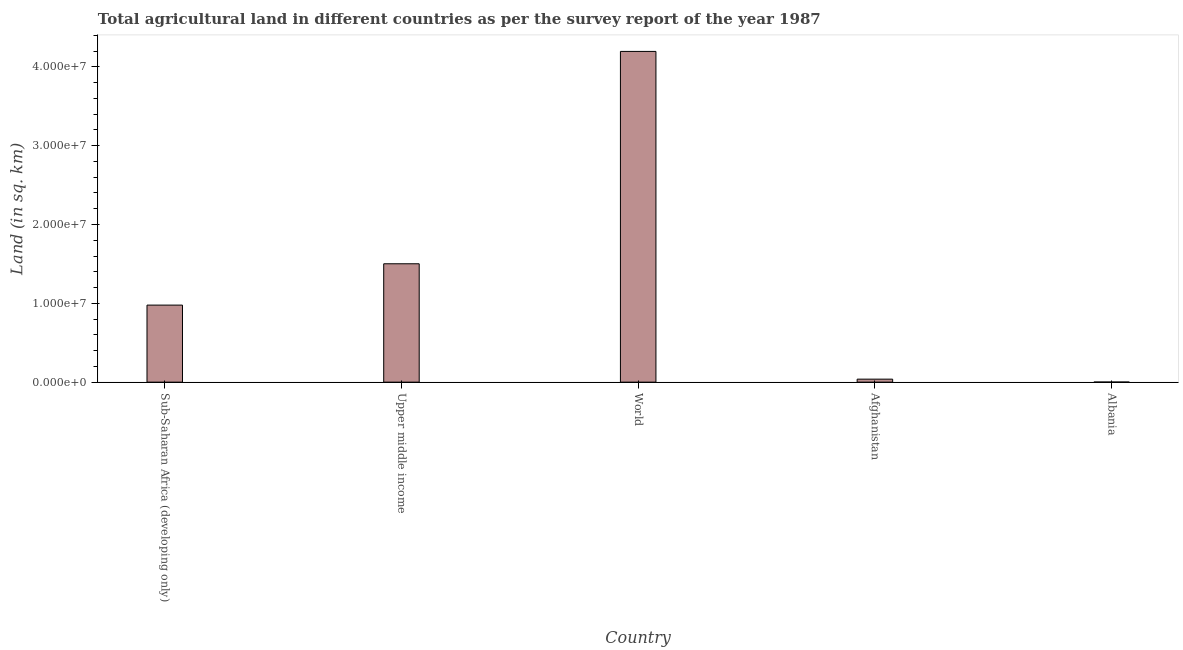Does the graph contain any zero values?
Offer a very short reply. No. Does the graph contain grids?
Ensure brevity in your answer.  No. What is the title of the graph?
Keep it short and to the point. Total agricultural land in different countries as per the survey report of the year 1987. What is the label or title of the X-axis?
Keep it short and to the point. Country. What is the label or title of the Y-axis?
Your response must be concise. Land (in sq. km). What is the agricultural land in Upper middle income?
Your answer should be compact. 1.50e+07. Across all countries, what is the maximum agricultural land?
Provide a succinct answer. 4.20e+07. Across all countries, what is the minimum agricultural land?
Your response must be concise. 1.11e+04. In which country was the agricultural land minimum?
Offer a terse response. Albania. What is the sum of the agricultural land?
Keep it short and to the point. 6.71e+07. What is the difference between the agricultural land in Albania and Sub-Saharan Africa (developing only)?
Your response must be concise. -9.76e+06. What is the average agricultural land per country?
Your answer should be very brief. 1.34e+07. What is the median agricultural land?
Provide a succinct answer. 9.77e+06. In how many countries, is the agricultural land greater than 2000000 sq. km?
Ensure brevity in your answer.  3. What is the ratio of the agricultural land in Afghanistan to that in Upper middle income?
Ensure brevity in your answer.  0.03. Is the difference between the agricultural land in Albania and Sub-Saharan Africa (developing only) greater than the difference between any two countries?
Make the answer very short. No. What is the difference between the highest and the second highest agricultural land?
Provide a succinct answer. 2.69e+07. What is the difference between the highest and the lowest agricultural land?
Provide a short and direct response. 4.19e+07. How many bars are there?
Your answer should be very brief. 5. Are all the bars in the graph horizontal?
Keep it short and to the point. No. What is the difference between two consecutive major ticks on the Y-axis?
Give a very brief answer. 1.00e+07. Are the values on the major ticks of Y-axis written in scientific E-notation?
Make the answer very short. Yes. What is the Land (in sq. km) of Sub-Saharan Africa (developing only)?
Offer a very short reply. 9.77e+06. What is the Land (in sq. km) in Upper middle income?
Make the answer very short. 1.50e+07. What is the Land (in sq. km) of World?
Keep it short and to the point. 4.20e+07. What is the Land (in sq. km) of Afghanistan?
Your response must be concise. 3.80e+05. What is the Land (in sq. km) in Albania?
Provide a succinct answer. 1.11e+04. What is the difference between the Land (in sq. km) in Sub-Saharan Africa (developing only) and Upper middle income?
Make the answer very short. -5.24e+06. What is the difference between the Land (in sq. km) in Sub-Saharan Africa (developing only) and World?
Keep it short and to the point. -3.22e+07. What is the difference between the Land (in sq. km) in Sub-Saharan Africa (developing only) and Afghanistan?
Offer a very short reply. 9.39e+06. What is the difference between the Land (in sq. km) in Sub-Saharan Africa (developing only) and Albania?
Keep it short and to the point. 9.76e+06. What is the difference between the Land (in sq. km) in Upper middle income and World?
Your answer should be very brief. -2.69e+07. What is the difference between the Land (in sq. km) in Upper middle income and Afghanistan?
Make the answer very short. 1.46e+07. What is the difference between the Land (in sq. km) in Upper middle income and Albania?
Provide a short and direct response. 1.50e+07. What is the difference between the Land (in sq. km) in World and Afghanistan?
Keep it short and to the point. 4.16e+07. What is the difference between the Land (in sq. km) in World and Albania?
Offer a very short reply. 4.19e+07. What is the difference between the Land (in sq. km) in Afghanistan and Albania?
Offer a terse response. 3.69e+05. What is the ratio of the Land (in sq. km) in Sub-Saharan Africa (developing only) to that in Upper middle income?
Provide a short and direct response. 0.65. What is the ratio of the Land (in sq. km) in Sub-Saharan Africa (developing only) to that in World?
Keep it short and to the point. 0.23. What is the ratio of the Land (in sq. km) in Sub-Saharan Africa (developing only) to that in Afghanistan?
Your answer should be very brief. 25.69. What is the ratio of the Land (in sq. km) in Sub-Saharan Africa (developing only) to that in Albania?
Your answer should be very brief. 879.82. What is the ratio of the Land (in sq. km) in Upper middle income to that in World?
Ensure brevity in your answer.  0.36. What is the ratio of the Land (in sq. km) in Upper middle income to that in Afghanistan?
Ensure brevity in your answer.  39.47. What is the ratio of the Land (in sq. km) in Upper middle income to that in Albania?
Your answer should be very brief. 1351.58. What is the ratio of the Land (in sq. km) in World to that in Afghanistan?
Give a very brief answer. 110.28. What is the ratio of the Land (in sq. km) in World to that in Albania?
Your response must be concise. 3776.42. What is the ratio of the Land (in sq. km) in Afghanistan to that in Albania?
Ensure brevity in your answer.  34.24. 